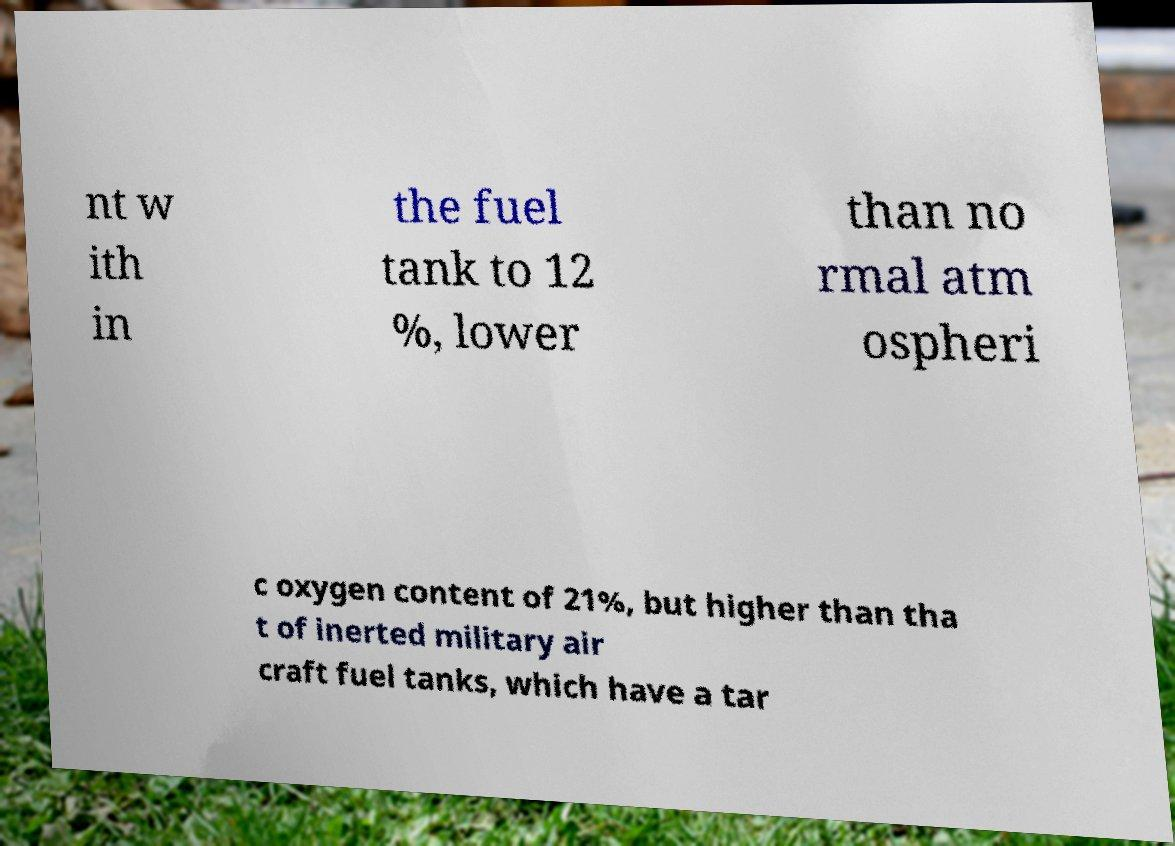Could you assist in decoding the text presented in this image and type it out clearly? nt w ith in the fuel tank to 12 %, lower than no rmal atm ospheri c oxygen content of 21%, but higher than tha t of inerted military air craft fuel tanks, which have a tar 